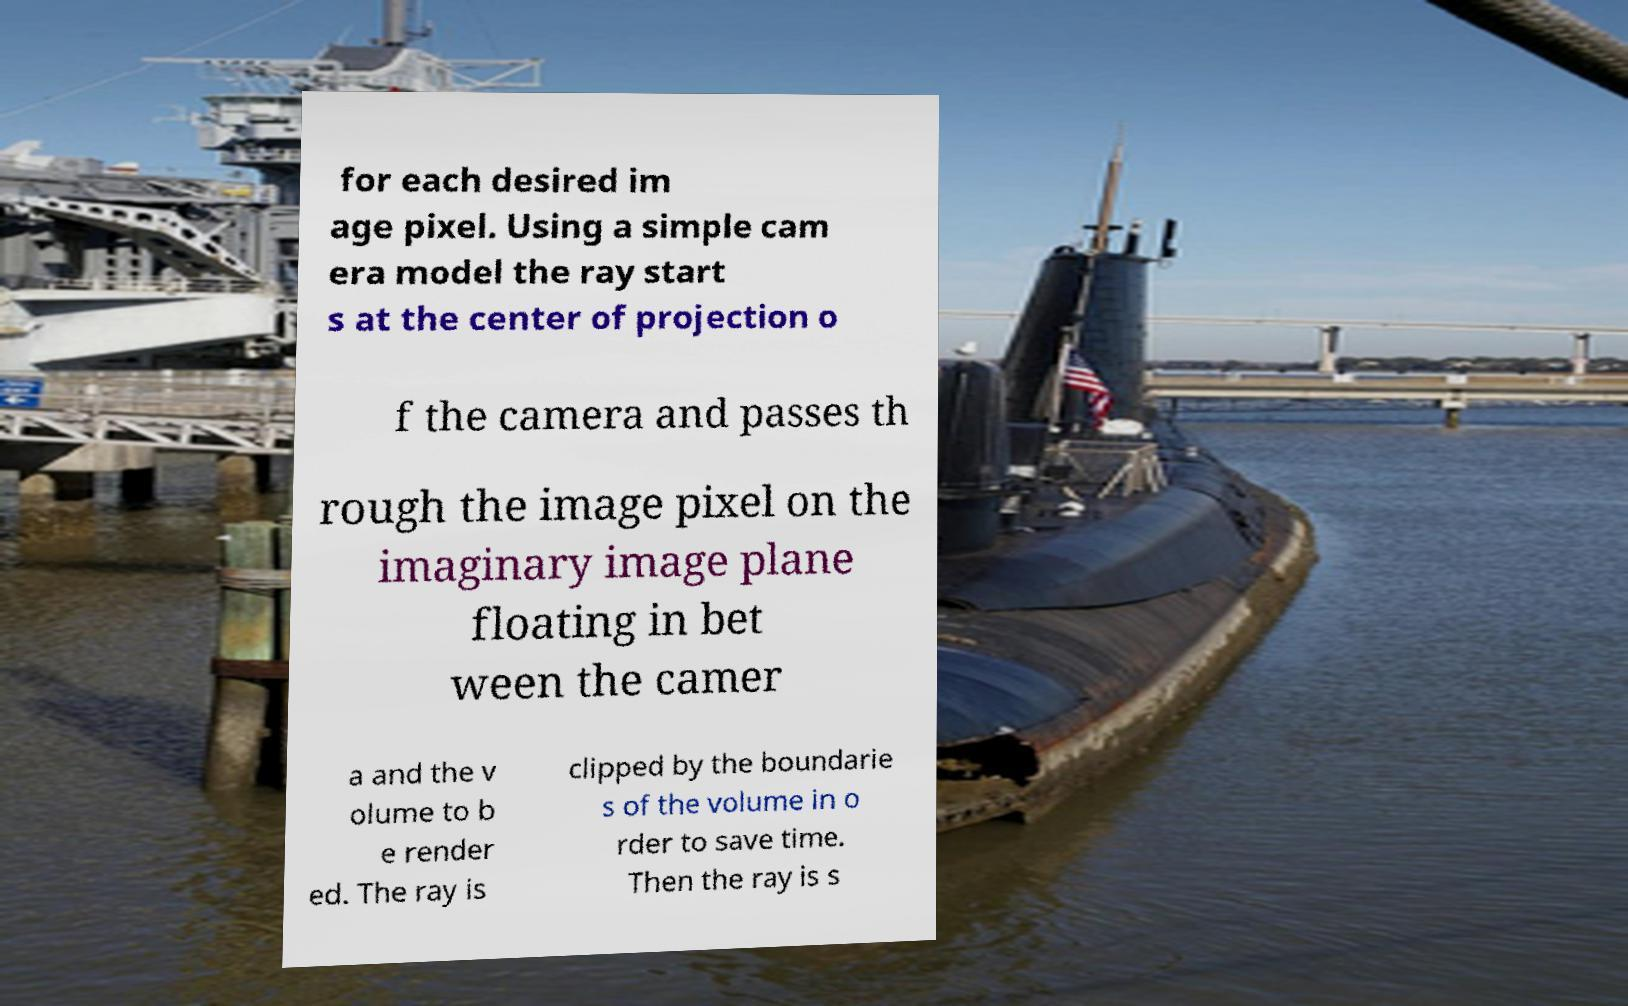Can you accurately transcribe the text from the provided image for me? for each desired im age pixel. Using a simple cam era model the ray start s at the center of projection o f the camera and passes th rough the image pixel on the imaginary image plane floating in bet ween the camer a and the v olume to b e render ed. The ray is clipped by the boundarie s of the volume in o rder to save time. Then the ray is s 